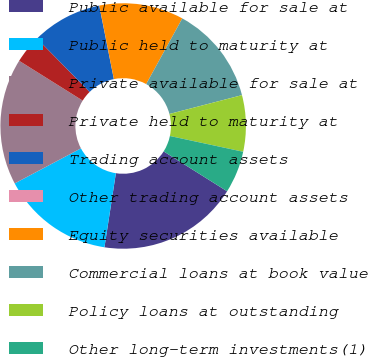<chart> <loc_0><loc_0><loc_500><loc_500><pie_chart><fcel>Public available for sale at<fcel>Public held to maturity at<fcel>Private available for sale at<fcel>Private held to maturity at<fcel>Trading account assets<fcel>Other trading account assets<fcel>Equity securities available<fcel>Commercial loans at book value<fcel>Policy loans at outstanding<fcel>Other long-term investments(1)<nl><fcel>18.51%<fcel>14.81%<fcel>16.66%<fcel>3.71%<fcel>9.26%<fcel>0.01%<fcel>11.11%<fcel>12.96%<fcel>7.41%<fcel>5.56%<nl></chart> 